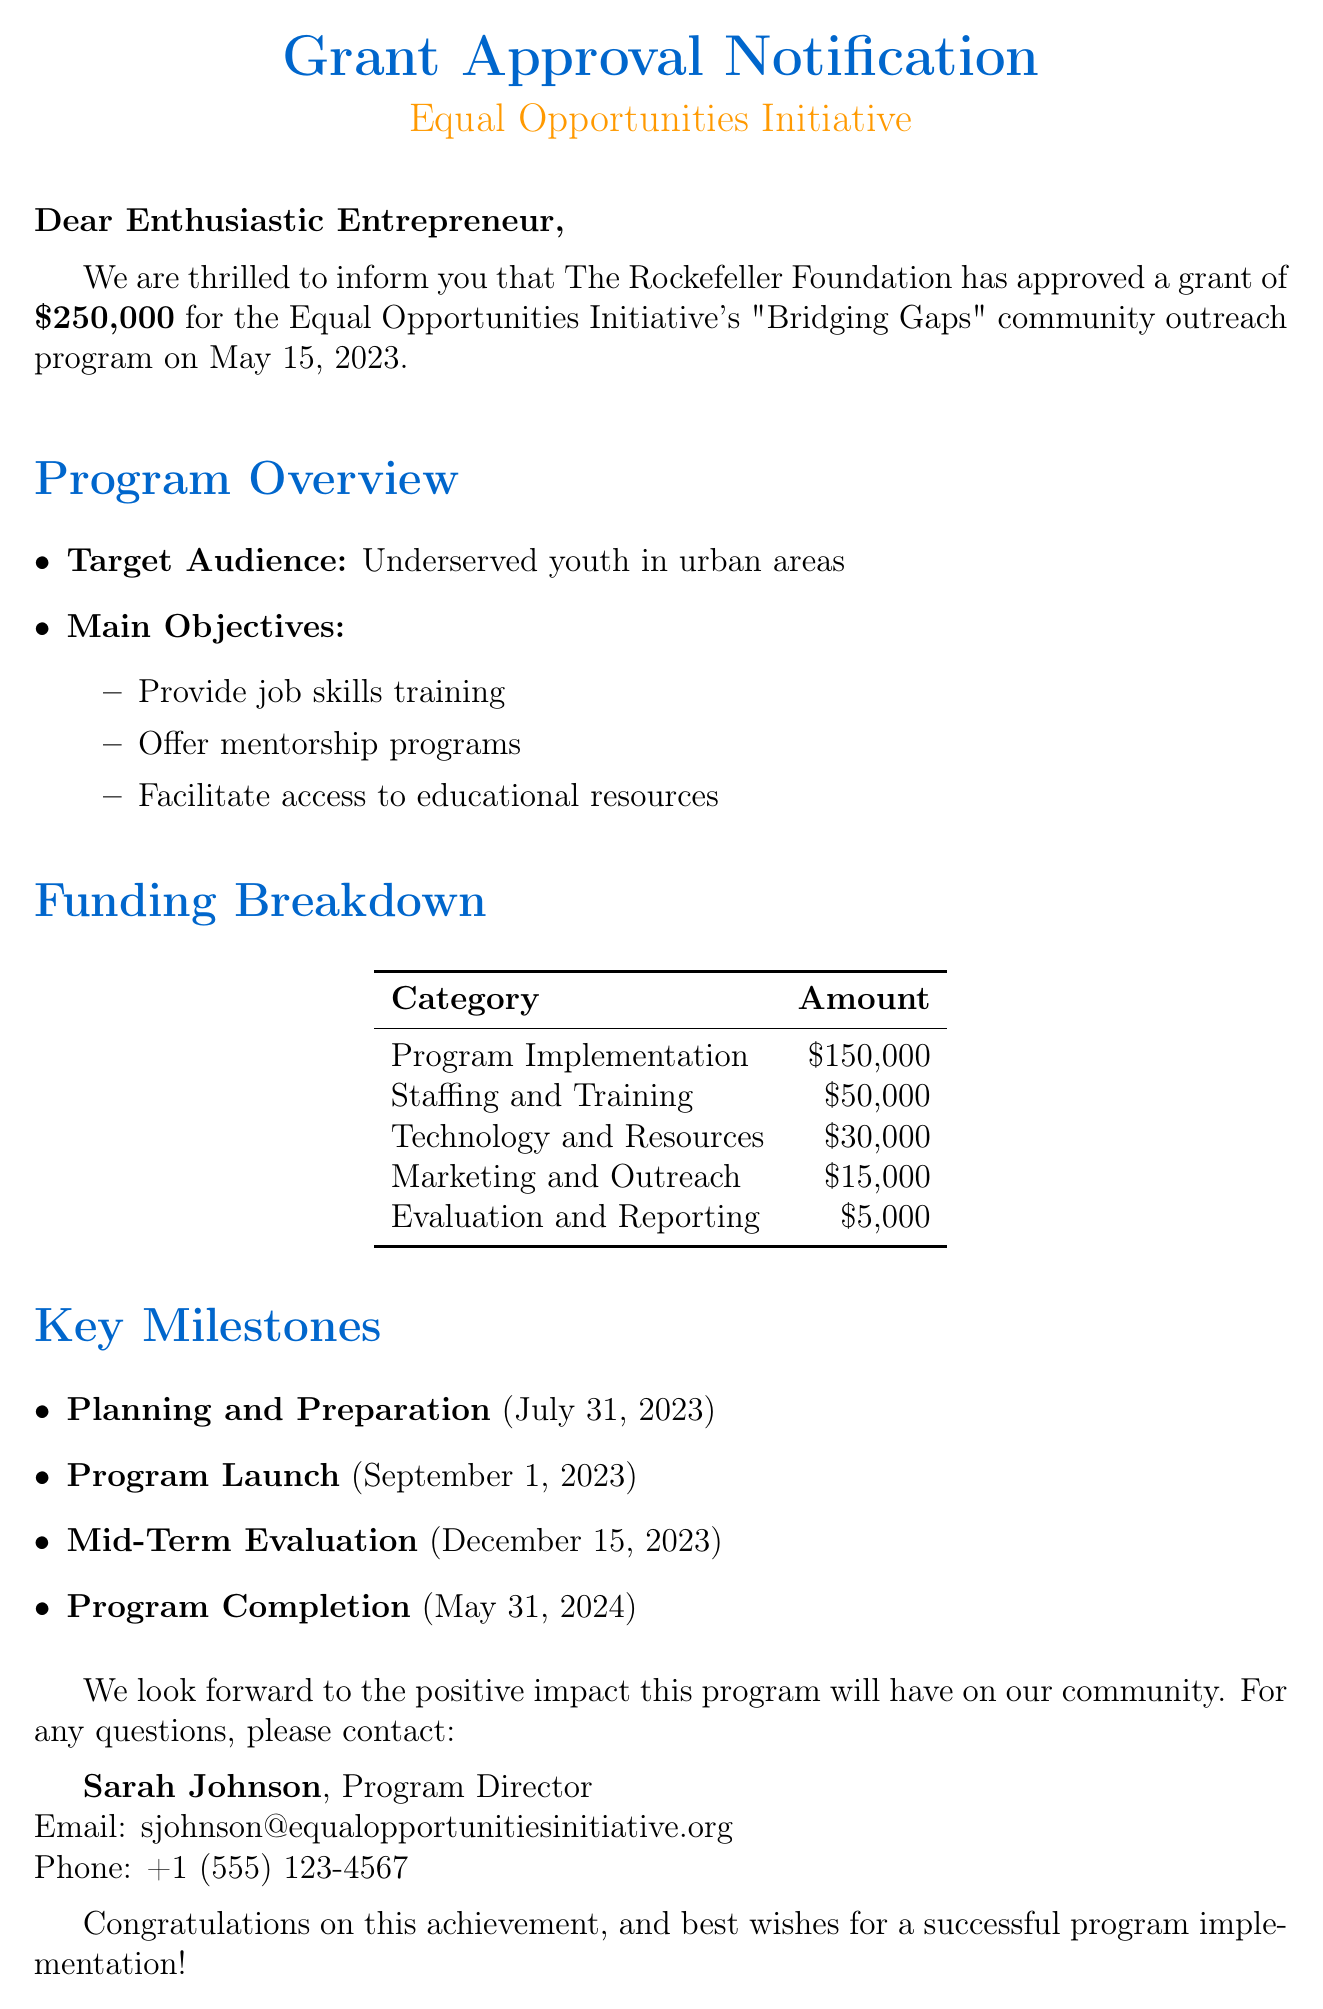What is the name of the grantor? The grantor is specified in the document as The Rockefeller Foundation.
Answer: The Rockefeller Foundation What is the grant amount approved? The document states the granted amount as $250,000 for the community outreach program.
Answer: $250,000 What is the target audience of the program? The document mentions that the target audience is underserved youth in urban areas.
Answer: Underserved youth in urban areas When is the program launch date? The document lists September 1, 2023, as the deadline for the program launch.
Answer: September 1, 2023 What percentage of the funding is allocated to program implementation? To find this, $150,000 for program implementation out of $250,000 total means 60%.
Answer: 60% What key task is included in the Planning and Preparation phase? The document lists "Recruit program staff" as one of the key tasks in this phase.
Answer: Recruit program staff Who is the program director? The contact information section specifies the program director's name as Sarah Johnson.
Answer: Sarah Johnson What is the deadline for the Mid-Term Evaluation? According to the document, the deadline for this evaluation is December 15, 2023.
Answer: December 15, 2023 What is the total budget for technology and resources? The funding breakdown shows that $30,000 has been allocated for technology and resources.
Answer: $30,000 